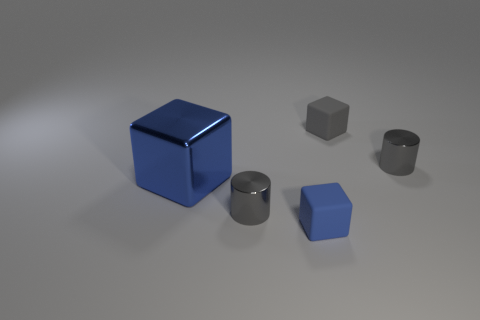Are there any other things that are the same size as the blue shiny object?
Give a very brief answer. No. The blue matte thing that is the same shape as the gray matte thing is what size?
Provide a succinct answer. Small. There is a cube that is both on the left side of the gray block and behind the tiny blue cube; how big is it?
Your response must be concise. Large. The small thing that is the same color as the big block is what shape?
Keep it short and to the point. Cube. The metallic block is what color?
Ensure brevity in your answer.  Blue. What is the size of the gray metal cylinder that is to the right of the tiny blue matte object?
Your answer should be compact. Small. There is a small gray cylinder in front of the tiny gray metallic cylinder that is to the right of the small gray rubber cube; how many matte objects are behind it?
Give a very brief answer. 1. What is the color of the big metallic cube that is to the left of the cylinder behind the blue metal thing?
Provide a short and direct response. Blue. Is there another gray cube of the same size as the gray block?
Offer a very short reply. No. The large blue block that is behind the gray thing in front of the big metal object behind the blue matte cube is made of what material?
Make the answer very short. Metal. 